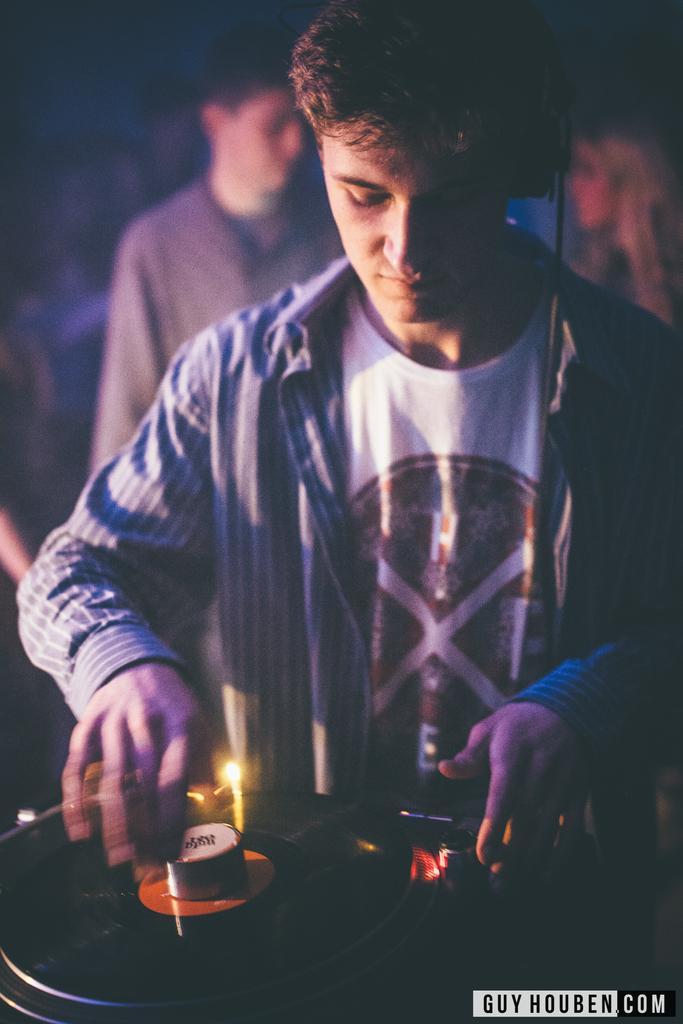Please provide a concise description of this image. In the picture I can see people among them the person in the front is holding something in the hand. I can also see a round shaped object. The background of the image is blurred. On the bottom right side of the image I can see a watermark. 